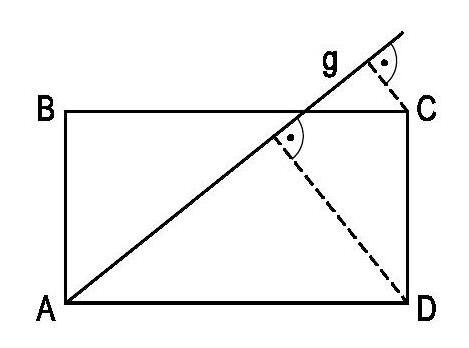The straight line $g$ runs through the vertex $A$ of the rectangle $ABCD$ shown. The perpendicular distance from $C$ to $g$ is 2 and from $D$ to $g$ is $6. AD is twice as long as $AB$. Determine the length of $AD$. To solve for the length of AD, we begin by noting that lines g and CD are parallel since g passes through the vertex A, and angle CAD is a right angle, making line g perpendicular to AD and hence parallel to CD. Given that the perpendicular distance from C to g is 2 units and from D to g is 6 units, we have two parallel line segments, CD and the segment on g between the perpendiculars from C and D, which form a trapezoid with the perpendiculars themselves. The height of this trapezoid is AD. Using the properties of similar triangles, we can set up the ratio (AD/AB) = (Perpendicular from D to g)/(Perpendicular from C to g), which simplifies with the given information to (AD/AB) = 6/2. Because AD is twice as long as AB, we replace AB with AD/2 in the ratio, obtaining (AD/(AD/2)) = 6/2, resulting in (2AD/AD) = 3, giving us AD = 3 * AB. Since we are given one ratio of the sides of the rectangle but not their actual lengths, we need to use the property of similar triangles again. The two similar right triangles are ADC and the smaller triangle formed by the perpendiculars and part of line g. By setting up the proportional relationship, we can determine that the length of AD must be 10 units since it is five times the distance from C to g. 